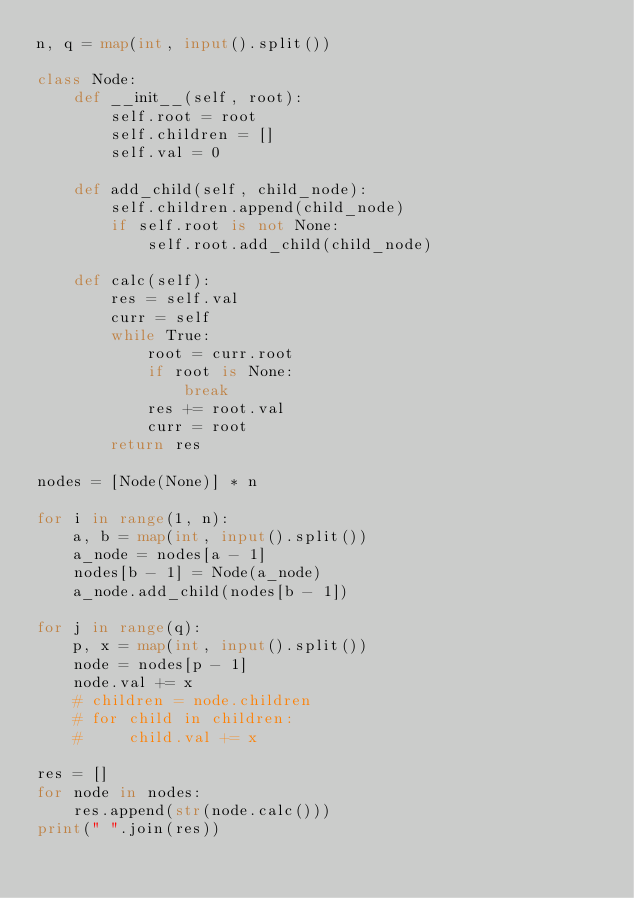<code> <loc_0><loc_0><loc_500><loc_500><_Python_>n, q = map(int, input().split())

class Node:
    def __init__(self, root):
        self.root = root
        self.children = []
        self.val = 0

    def add_child(self, child_node):
        self.children.append(child_node)
        if self.root is not None:
            self.root.add_child(child_node)

    def calc(self):
        res = self.val
        curr = self
        while True:
            root = curr.root
            if root is None:
                break
            res += root.val
            curr = root
        return res

nodes = [Node(None)] * n

for i in range(1, n):
    a, b = map(int, input().split())
    a_node = nodes[a - 1]
    nodes[b - 1] = Node(a_node)
    a_node.add_child(nodes[b - 1])

for j in range(q):
    p, x = map(int, input().split())
    node = nodes[p - 1]
    node.val += x
    # children = node.children
    # for child in children:
    #     child.val += x

res = []
for node in nodes:
    res.append(str(node.calc()))
print(" ".join(res))</code> 